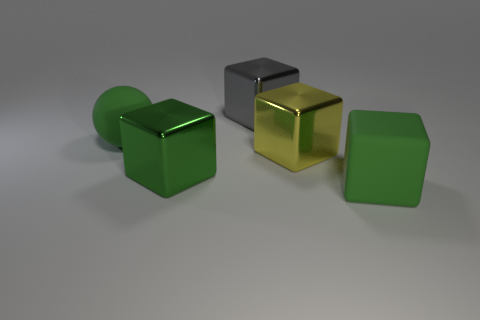Subtract all big shiny cubes. How many cubes are left? 1 Subtract all blue cylinders. How many green cubes are left? 2 Subtract all yellow cubes. How many cubes are left? 3 Add 2 gray metal cubes. How many objects exist? 7 Subtract all spheres. How many objects are left? 4 Subtract all brown cubes. Subtract all brown balls. How many cubes are left? 4 Subtract 0 blue spheres. How many objects are left? 5 Subtract all big green matte balls. Subtract all yellow metal blocks. How many objects are left? 3 Add 4 big yellow metallic things. How many big yellow metallic things are left? 5 Add 3 large things. How many large things exist? 8 